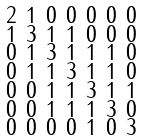<formula> <loc_0><loc_0><loc_500><loc_500>\begin{smallmatrix} 2 & 1 & 0 & 0 & 0 & 0 & 0 \\ 1 & 3 & 1 & 1 & 0 & 0 & 0 \\ 0 & 1 & 3 & 1 & 1 & 1 & 0 \\ 0 & 1 & 1 & 3 & 1 & 1 & 0 \\ 0 & 0 & 1 & 1 & 3 & 1 & 1 \\ 0 & 0 & 1 & 1 & 1 & 3 & 0 \\ 0 & 0 & 0 & 0 & 1 & 0 & 3 \end{smallmatrix}</formula> 